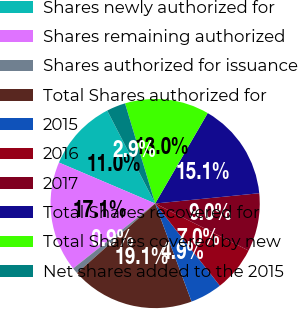Convert chart to OTSL. <chart><loc_0><loc_0><loc_500><loc_500><pie_chart><fcel>Shares newly authorized for<fcel>Shares remaining authorized<fcel>Shares authorized for issuance<fcel>Total Shares authorized for<fcel>2015<fcel>2016<fcel>2017<fcel>Total Shares recovered for<fcel>Total Shares covered by new<fcel>Net shares added to the 2015<nl><fcel>11.01%<fcel>17.07%<fcel>0.92%<fcel>19.08%<fcel>4.95%<fcel>6.97%<fcel>8.99%<fcel>15.05%<fcel>13.03%<fcel>2.93%<nl></chart> 